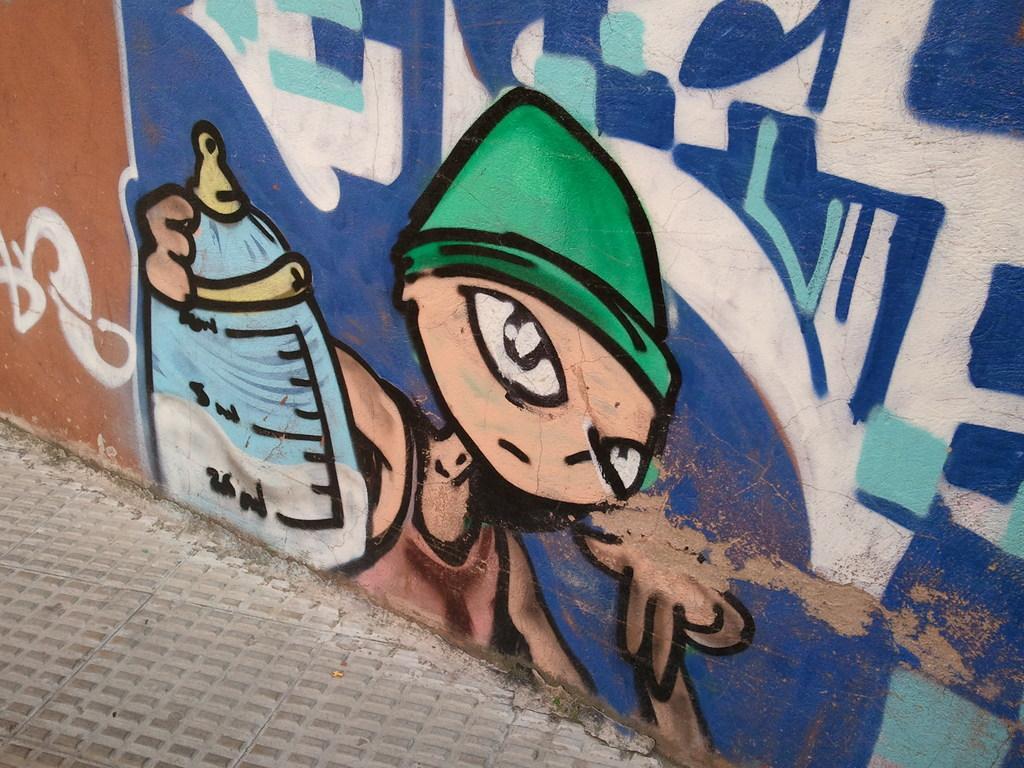How would you summarize this image in a sentence or two? This image consists of a wall. On which there is a painting of a boy holding a bottle. At the bottom, there is a road. 